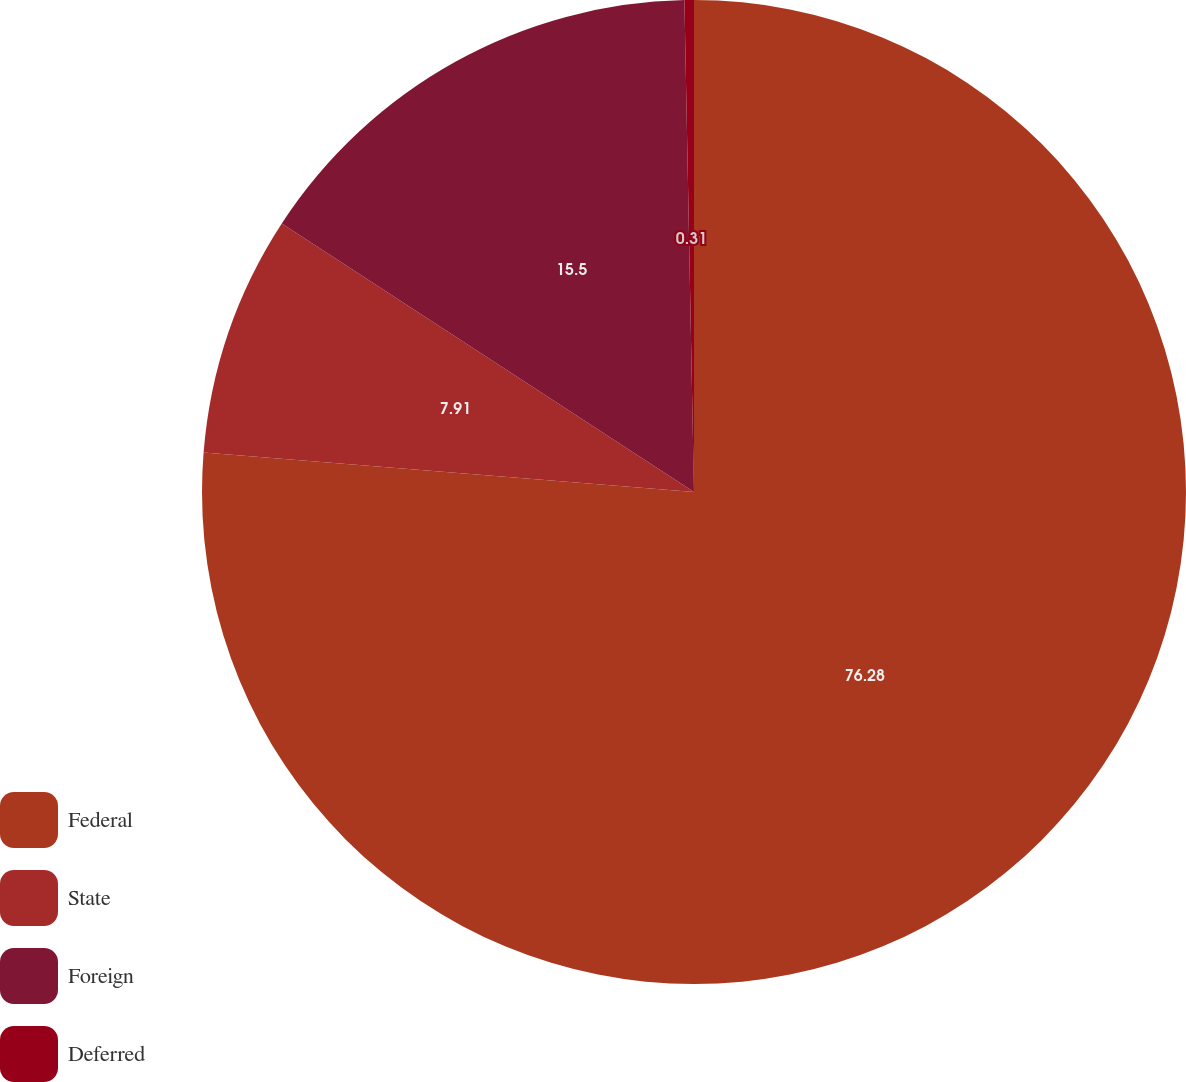Convert chart to OTSL. <chart><loc_0><loc_0><loc_500><loc_500><pie_chart><fcel>Federal<fcel>State<fcel>Foreign<fcel>Deferred<nl><fcel>76.28%<fcel>7.91%<fcel>15.5%<fcel>0.31%<nl></chart> 